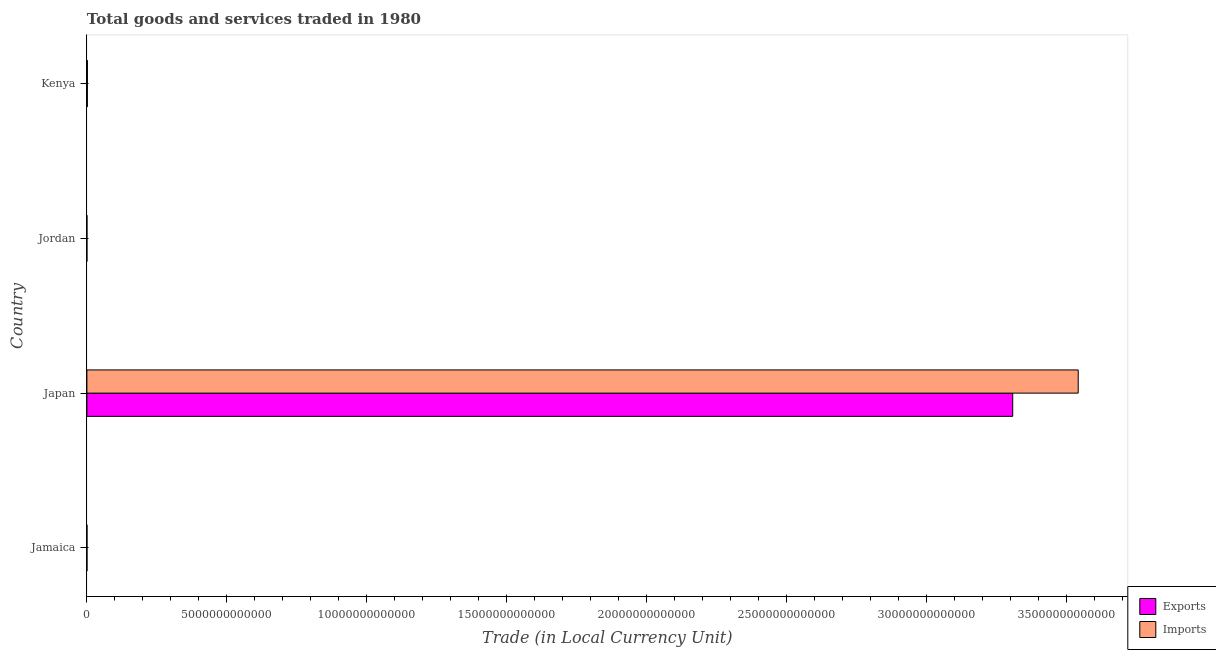How many groups of bars are there?
Give a very brief answer. 4. Are the number of bars per tick equal to the number of legend labels?
Offer a very short reply. Yes. Are the number of bars on each tick of the Y-axis equal?
Keep it short and to the point. Yes. How many bars are there on the 1st tick from the top?
Keep it short and to the point. 2. What is the export of goods and services in Jamaica?
Provide a short and direct response. 2.44e+09. Across all countries, what is the maximum imports of goods and services?
Keep it short and to the point. 3.54e+13. Across all countries, what is the minimum export of goods and services?
Ensure brevity in your answer.  4.70e+08. In which country was the export of goods and services maximum?
Your answer should be very brief. Japan. In which country was the export of goods and services minimum?
Make the answer very short. Jordan. What is the total export of goods and services in the graph?
Make the answer very short. 3.31e+13. What is the difference between the imports of goods and services in Jamaica and that in Japan?
Provide a short and direct response. -3.54e+13. What is the difference between the imports of goods and services in Kenya and the export of goods and services in Japan?
Make the answer very short. -3.31e+13. What is the average imports of goods and services per country?
Provide a short and direct response. 8.86e+12. What is the difference between the imports of goods and services and export of goods and services in Kenya?
Your response must be concise. 3.44e+09. In how many countries, is the export of goods and services greater than 24000000000000 LCU?
Give a very brief answer. 1. What is the ratio of the export of goods and services in Jamaica to that in Jordan?
Offer a terse response. 5.18. Is the export of goods and services in Jamaica less than that in Kenya?
Offer a terse response. Yes. What is the difference between the highest and the second highest imports of goods and services?
Provide a succinct answer. 3.54e+13. What is the difference between the highest and the lowest imports of goods and services?
Make the answer very short. 3.54e+13. In how many countries, is the imports of goods and services greater than the average imports of goods and services taken over all countries?
Give a very brief answer. 1. What does the 1st bar from the top in Jordan represents?
Provide a short and direct response. Imports. What does the 2nd bar from the bottom in Jamaica represents?
Offer a terse response. Imports. How many bars are there?
Offer a very short reply. 8. What is the difference between two consecutive major ticks on the X-axis?
Give a very brief answer. 5.00e+12. Does the graph contain any zero values?
Your response must be concise. No. Does the graph contain grids?
Ensure brevity in your answer.  No. How are the legend labels stacked?
Offer a terse response. Vertical. What is the title of the graph?
Provide a succinct answer. Total goods and services traded in 1980. Does "Urban" appear as one of the legend labels in the graph?
Keep it short and to the point. No. What is the label or title of the X-axis?
Your answer should be compact. Trade (in Local Currency Unit). What is the label or title of the Y-axis?
Provide a short and direct response. Country. What is the Trade (in Local Currency Unit) of Exports in Jamaica?
Provide a succinct answer. 2.44e+09. What is the Trade (in Local Currency Unit) of Imports in Jamaica?
Give a very brief answer. 2.44e+09. What is the Trade (in Local Currency Unit) of Exports in Japan?
Make the answer very short. 3.31e+13. What is the Trade (in Local Currency Unit) of Imports in Japan?
Make the answer very short. 3.54e+13. What is the Trade (in Local Currency Unit) of Exports in Jordan?
Provide a short and direct response. 4.70e+08. What is the Trade (in Local Currency Unit) of Imports in Jordan?
Offer a very short reply. 9.94e+08. What is the Trade (in Local Currency Unit) of Exports in Kenya?
Keep it short and to the point. 1.59e+1. What is the Trade (in Local Currency Unit) of Imports in Kenya?
Ensure brevity in your answer.  1.94e+1. Across all countries, what is the maximum Trade (in Local Currency Unit) in Exports?
Keep it short and to the point. 3.31e+13. Across all countries, what is the maximum Trade (in Local Currency Unit) in Imports?
Give a very brief answer. 3.54e+13. Across all countries, what is the minimum Trade (in Local Currency Unit) in Exports?
Your answer should be compact. 4.70e+08. Across all countries, what is the minimum Trade (in Local Currency Unit) in Imports?
Ensure brevity in your answer.  9.94e+08. What is the total Trade (in Local Currency Unit) of Exports in the graph?
Offer a very short reply. 3.31e+13. What is the total Trade (in Local Currency Unit) in Imports in the graph?
Offer a terse response. 3.54e+13. What is the difference between the Trade (in Local Currency Unit) in Exports in Jamaica and that in Japan?
Your answer should be very brief. -3.31e+13. What is the difference between the Trade (in Local Currency Unit) of Imports in Jamaica and that in Japan?
Keep it short and to the point. -3.54e+13. What is the difference between the Trade (in Local Currency Unit) in Exports in Jamaica and that in Jordan?
Offer a very short reply. 1.97e+09. What is the difference between the Trade (in Local Currency Unit) in Imports in Jamaica and that in Jordan?
Provide a short and direct response. 1.44e+09. What is the difference between the Trade (in Local Currency Unit) of Exports in Jamaica and that in Kenya?
Give a very brief answer. -1.35e+1. What is the difference between the Trade (in Local Currency Unit) in Imports in Jamaica and that in Kenya?
Keep it short and to the point. -1.69e+1. What is the difference between the Trade (in Local Currency Unit) of Exports in Japan and that in Jordan?
Your answer should be compact. 3.31e+13. What is the difference between the Trade (in Local Currency Unit) of Imports in Japan and that in Jordan?
Your response must be concise. 3.54e+13. What is the difference between the Trade (in Local Currency Unit) in Exports in Japan and that in Kenya?
Provide a short and direct response. 3.31e+13. What is the difference between the Trade (in Local Currency Unit) of Imports in Japan and that in Kenya?
Ensure brevity in your answer.  3.54e+13. What is the difference between the Trade (in Local Currency Unit) in Exports in Jordan and that in Kenya?
Your response must be concise. -1.54e+1. What is the difference between the Trade (in Local Currency Unit) of Imports in Jordan and that in Kenya?
Ensure brevity in your answer.  -1.84e+1. What is the difference between the Trade (in Local Currency Unit) in Exports in Jamaica and the Trade (in Local Currency Unit) in Imports in Japan?
Your answer should be very brief. -3.54e+13. What is the difference between the Trade (in Local Currency Unit) of Exports in Jamaica and the Trade (in Local Currency Unit) of Imports in Jordan?
Your answer should be very brief. 1.44e+09. What is the difference between the Trade (in Local Currency Unit) in Exports in Jamaica and the Trade (in Local Currency Unit) in Imports in Kenya?
Your response must be concise. -1.69e+1. What is the difference between the Trade (in Local Currency Unit) of Exports in Japan and the Trade (in Local Currency Unit) of Imports in Jordan?
Offer a very short reply. 3.31e+13. What is the difference between the Trade (in Local Currency Unit) of Exports in Japan and the Trade (in Local Currency Unit) of Imports in Kenya?
Your response must be concise. 3.31e+13. What is the difference between the Trade (in Local Currency Unit) of Exports in Jordan and the Trade (in Local Currency Unit) of Imports in Kenya?
Provide a succinct answer. -1.89e+1. What is the average Trade (in Local Currency Unit) of Exports per country?
Ensure brevity in your answer.  8.28e+12. What is the average Trade (in Local Currency Unit) in Imports per country?
Offer a terse response. 8.86e+12. What is the difference between the Trade (in Local Currency Unit) of Exports and Trade (in Local Currency Unit) of Imports in Jamaica?
Offer a terse response. 1.30e+06. What is the difference between the Trade (in Local Currency Unit) of Exports and Trade (in Local Currency Unit) of Imports in Japan?
Your answer should be very brief. -2.34e+12. What is the difference between the Trade (in Local Currency Unit) of Exports and Trade (in Local Currency Unit) of Imports in Jordan?
Provide a short and direct response. -5.23e+08. What is the difference between the Trade (in Local Currency Unit) in Exports and Trade (in Local Currency Unit) in Imports in Kenya?
Your response must be concise. -3.44e+09. What is the ratio of the Trade (in Local Currency Unit) of Exports in Jamaica to that in Japan?
Offer a very short reply. 0. What is the ratio of the Trade (in Local Currency Unit) in Imports in Jamaica to that in Japan?
Ensure brevity in your answer.  0. What is the ratio of the Trade (in Local Currency Unit) in Exports in Jamaica to that in Jordan?
Your answer should be compact. 5.18. What is the ratio of the Trade (in Local Currency Unit) of Imports in Jamaica to that in Jordan?
Keep it short and to the point. 2.45. What is the ratio of the Trade (in Local Currency Unit) in Exports in Jamaica to that in Kenya?
Your response must be concise. 0.15. What is the ratio of the Trade (in Local Currency Unit) of Imports in Jamaica to that in Kenya?
Provide a short and direct response. 0.13. What is the ratio of the Trade (in Local Currency Unit) in Exports in Japan to that in Jordan?
Your answer should be very brief. 7.03e+04. What is the ratio of the Trade (in Local Currency Unit) in Imports in Japan to that in Jordan?
Make the answer very short. 3.56e+04. What is the ratio of the Trade (in Local Currency Unit) of Exports in Japan to that in Kenya?
Keep it short and to the point. 2078.99. What is the ratio of the Trade (in Local Currency Unit) in Imports in Japan to that in Kenya?
Provide a succinct answer. 1830.27. What is the ratio of the Trade (in Local Currency Unit) in Exports in Jordan to that in Kenya?
Your response must be concise. 0.03. What is the ratio of the Trade (in Local Currency Unit) of Imports in Jordan to that in Kenya?
Give a very brief answer. 0.05. What is the difference between the highest and the second highest Trade (in Local Currency Unit) in Exports?
Ensure brevity in your answer.  3.31e+13. What is the difference between the highest and the second highest Trade (in Local Currency Unit) in Imports?
Give a very brief answer. 3.54e+13. What is the difference between the highest and the lowest Trade (in Local Currency Unit) of Exports?
Offer a terse response. 3.31e+13. What is the difference between the highest and the lowest Trade (in Local Currency Unit) in Imports?
Provide a succinct answer. 3.54e+13. 